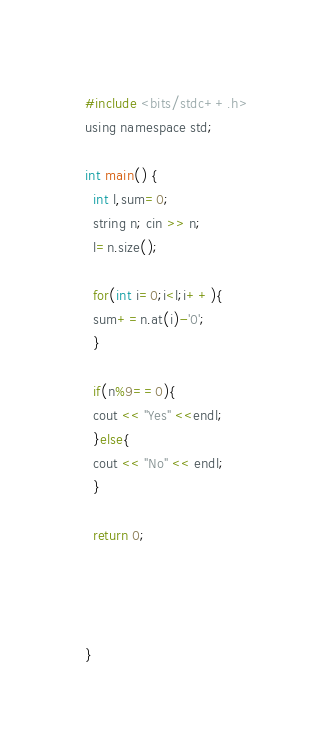<code> <loc_0><loc_0><loc_500><loc_500><_C_>#include <bits/stdc++.h>
using namespace std;

int main() {
  int l,sum=0;
  string n; cin >> n;
  l=n.size();
  
  for(int i=0;i<l;i++){
  sum+=n.at(i)-'0';
  }
  
  if(n%9==0){
  cout << "Yes" <<endl;
  }else{
  cout << "No" << endl;
  }
  
  return 0;
  
  
  
  
}
</code> 